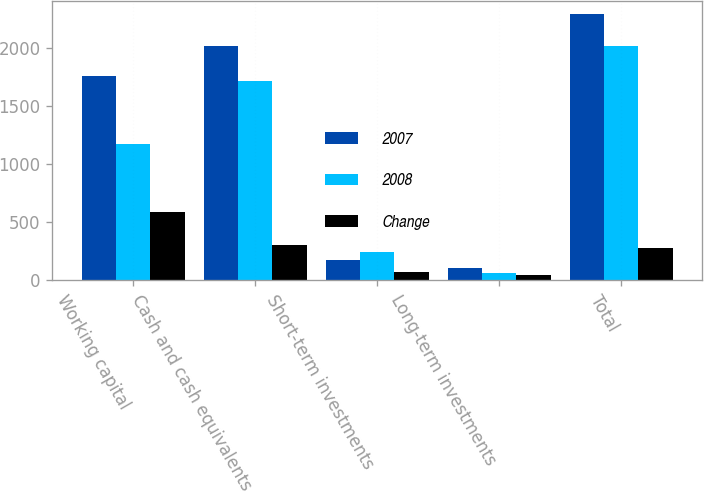<chart> <loc_0><loc_0><loc_500><loc_500><stacked_bar_chart><ecel><fcel>Working capital<fcel>Cash and cash equivalents<fcel>Short-term investments<fcel>Long-term investments<fcel>Total<nl><fcel>2007<fcel>1759.6<fcel>2019.1<fcel>172.9<fcel>101.4<fcel>2293.4<nl><fcel>2008<fcel>1175.3<fcel>1716.1<fcel>240.4<fcel>59.3<fcel>2015.8<nl><fcel>Change<fcel>584.3<fcel>303<fcel>67.5<fcel>42.1<fcel>277.6<nl></chart> 